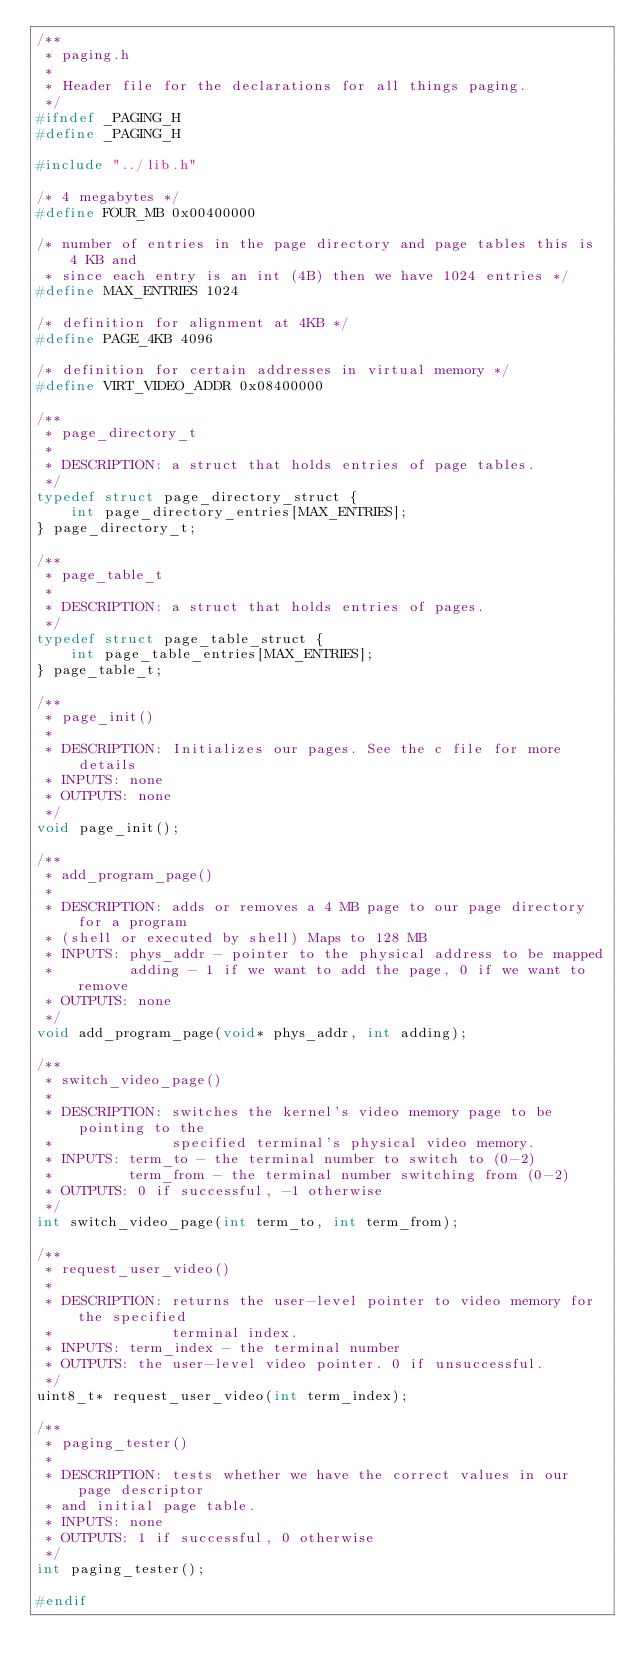<code> <loc_0><loc_0><loc_500><loc_500><_C_>/**
 * paging.h
 *
 * Header file for the declarations for all things paging.
 */
#ifndef _PAGING_H
#define _PAGING_H

#include "../lib.h"

/* 4 megabytes */
#define FOUR_MB 0x00400000

/* number of entries in the page directory and page tables this is 4 KB and
 * since each entry is an int (4B) then we have 1024 entries */
#define MAX_ENTRIES 1024

/* definition for alignment at 4KB */
#define PAGE_4KB 4096

/* definition for certain addresses in virtual memory */
#define VIRT_VIDEO_ADDR 0x08400000

/**
 * page_directory_t
 *
 * DESCRIPTION: a struct that holds entries of page tables.
 */
typedef struct page_directory_struct {
    int page_directory_entries[MAX_ENTRIES];
} page_directory_t;

/**
 * page_table_t
 *
 * DESCRIPTION: a struct that holds entries of pages.
 */
typedef struct page_table_struct {
    int page_table_entries[MAX_ENTRIES];
} page_table_t;

/**
 * page_init()
 *
 * DESCRIPTION: Initializes our pages. See the c file for more details
 * INPUTS: none
 * OUTPUTS: none
 */
void page_init();

/**
 * add_program_page()
 *
 * DESCRIPTION: adds or removes a 4 MB page to our page directory for a program
 * (shell or executed by shell) Maps to 128 MB
 * INPUTS: phys_addr - pointer to the physical address to be mapped
 *         adding - 1 if we want to add the page, 0 if we want to remove
 * OUTPUTS: none
 */
void add_program_page(void* phys_addr, int adding);

/**
 * switch_video_page()
 *
 * DESCRIPTION: switches the kernel's video memory page to be pointing to the
 *              specified terminal's physical video memory.
 * INPUTS: term_to - the terminal number to switch to (0-2)
 *         term_from - the terminal number switching from (0-2)
 * OUTPUTS: 0 if successful, -1 otherwise
 */
int switch_video_page(int term_to, int term_from);

/**
 * request_user_video()
 *
 * DESCRIPTION: returns the user-level pointer to video memory for the specified
 *              terminal index.
 * INPUTS: term_index - the terminal number
 * OUTPUTS: the user-level video pointer. 0 if unsuccessful.
 */
uint8_t* request_user_video(int term_index);

/**
 * paging_tester()
 *
 * DESCRIPTION: tests whether we have the correct values in our page descriptor
 * and initial page table.
 * INPUTS: none
 * OUTPUTS: 1 if successful, 0 otherwise
 */
int paging_tester();

#endif
</code> 